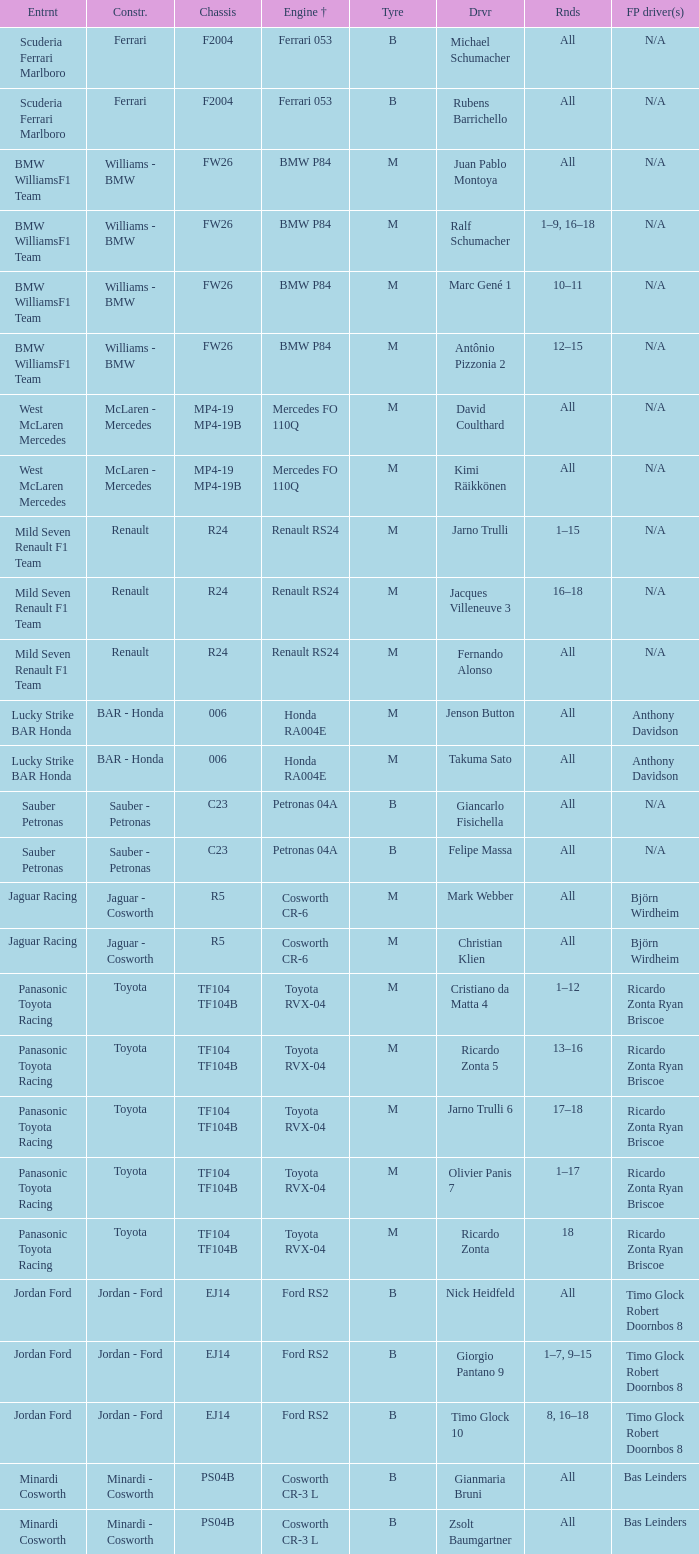What kind of free practice is there with a Ford RS2 engine +? Timo Glock Robert Doornbos 8, Timo Glock Robert Doornbos 8, Timo Glock Robert Doornbos 8. 